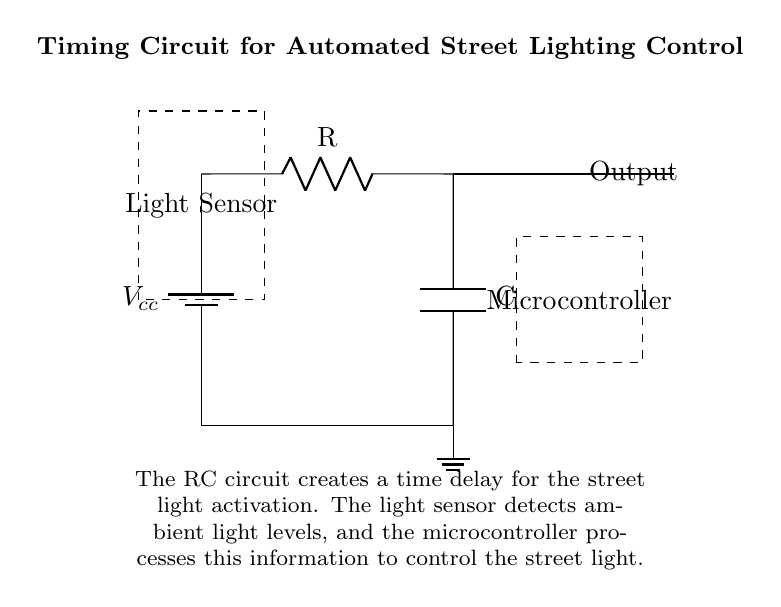What is the power supply voltage in the circuit? The voltage provided by the power supply is labeled as Vcc at the battery symbol in the diagram. Since there are no additional specifications given, it is common to refer to it simply as Vcc in circuit diagrams.
Answer: Vcc What does the capacitor in the circuit do? The capacitor in this circuit is used to create a time delay for activating the street light. It charges and discharges, affecting the time it takes for the output signal to change in response to the light sensor.
Answer: Time delay What component detects the light levels? The component responsible for detecting light levels is the light sensor, which is located to the left of the circuit and denoted with a dashed rectangle. Its function is to sense the ambient light and provide input to the microcontroller.
Answer: Light sensor How does the microcontroller interact with the circuit? The microcontroller receives signals from the light sensor about ambient light levels and processes this information to control the street light on or off, thus directly affecting its operation.
Answer: Control street light What is the expected effect of increasing the capacitor value in this circuit? Increasing the capacitor value in an RC timing circuit will lead to a longer charge and discharge time, meaning the time delay for the street light activation will increase. This results in the light staying on for a longer duration after sunset.
Answer: Longer delay What type of circuit configuration is used in the design? This design employs a resistor-capacitor (RC) timing configuration, which is specifically suited for creating time delays in electronic circuits. Such configurations are common in automation and delay mechanisms.
Answer: RC timing circuit What is the role of the resistor in this timing circuit? The resistor in the timing circuit works in conjunction with the capacitor to determine the charge and discharge rate. It regulates the amount of current flowing into the capacitor, which directly affects the timing behavior of the circuit.
Answer: Regulates current 